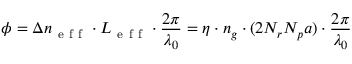<formula> <loc_0><loc_0><loc_500><loc_500>\phi = \Delta n _ { e f f } \cdot L _ { e f f } \cdot \frac { 2 \pi } { \lambda _ { 0 } } = \eta \cdot n _ { g } \cdot ( 2 N _ { r } N _ { p } a ) \cdot \frac { 2 \pi } { \lambda _ { 0 } }</formula> 